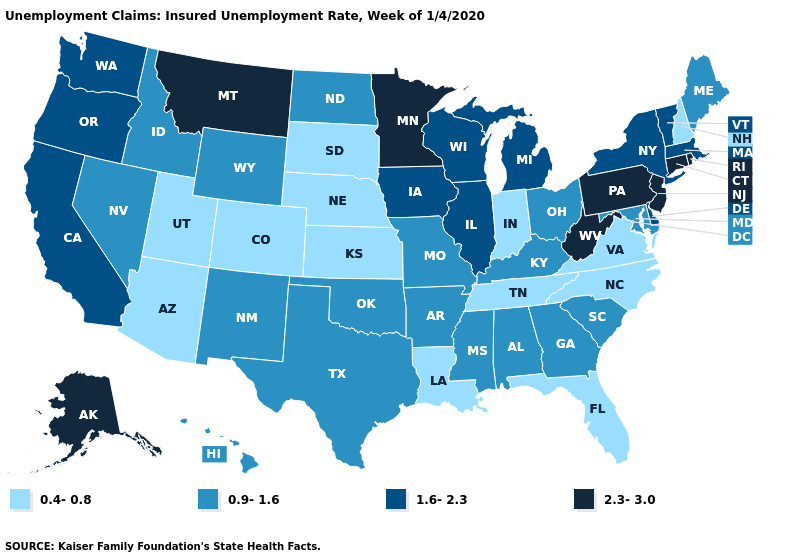What is the value of Alaska?
Short answer required. 2.3-3.0. Name the states that have a value in the range 0.9-1.6?
Answer briefly. Alabama, Arkansas, Georgia, Hawaii, Idaho, Kentucky, Maine, Maryland, Mississippi, Missouri, Nevada, New Mexico, North Dakota, Ohio, Oklahoma, South Carolina, Texas, Wyoming. Does Washington have the highest value in the West?
Keep it brief. No. What is the value of Maryland?
Be succinct. 0.9-1.6. What is the lowest value in states that border Florida?
Give a very brief answer. 0.9-1.6. What is the value of Oregon?
Short answer required. 1.6-2.3. Does North Dakota have a higher value than Virginia?
Be succinct. Yes. What is the highest value in states that border New Jersey?
Give a very brief answer. 2.3-3.0. Among the states that border Illinois , which have the highest value?
Concise answer only. Iowa, Wisconsin. How many symbols are there in the legend?
Answer briefly. 4. What is the value of Vermont?
Keep it brief. 1.6-2.3. What is the value of Idaho?
Short answer required. 0.9-1.6. What is the value of Indiana?
Answer briefly. 0.4-0.8. Which states have the lowest value in the South?
Keep it brief. Florida, Louisiana, North Carolina, Tennessee, Virginia. Name the states that have a value in the range 2.3-3.0?
Answer briefly. Alaska, Connecticut, Minnesota, Montana, New Jersey, Pennsylvania, Rhode Island, West Virginia. 